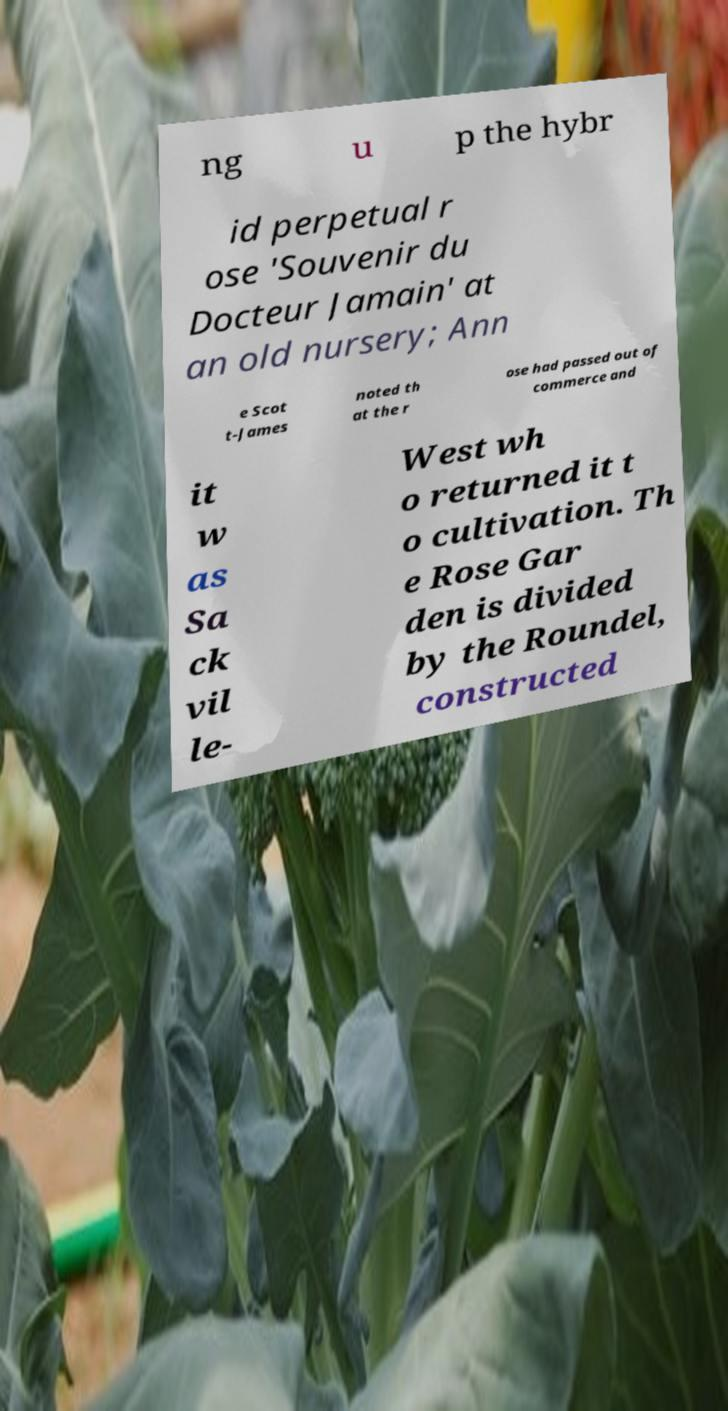There's text embedded in this image that I need extracted. Can you transcribe it verbatim? ng u p the hybr id perpetual r ose 'Souvenir du Docteur Jamain' at an old nursery; Ann e Scot t-James noted th at the r ose had passed out of commerce and it w as Sa ck vil le- West wh o returned it t o cultivation. Th e Rose Gar den is divided by the Roundel, constructed 